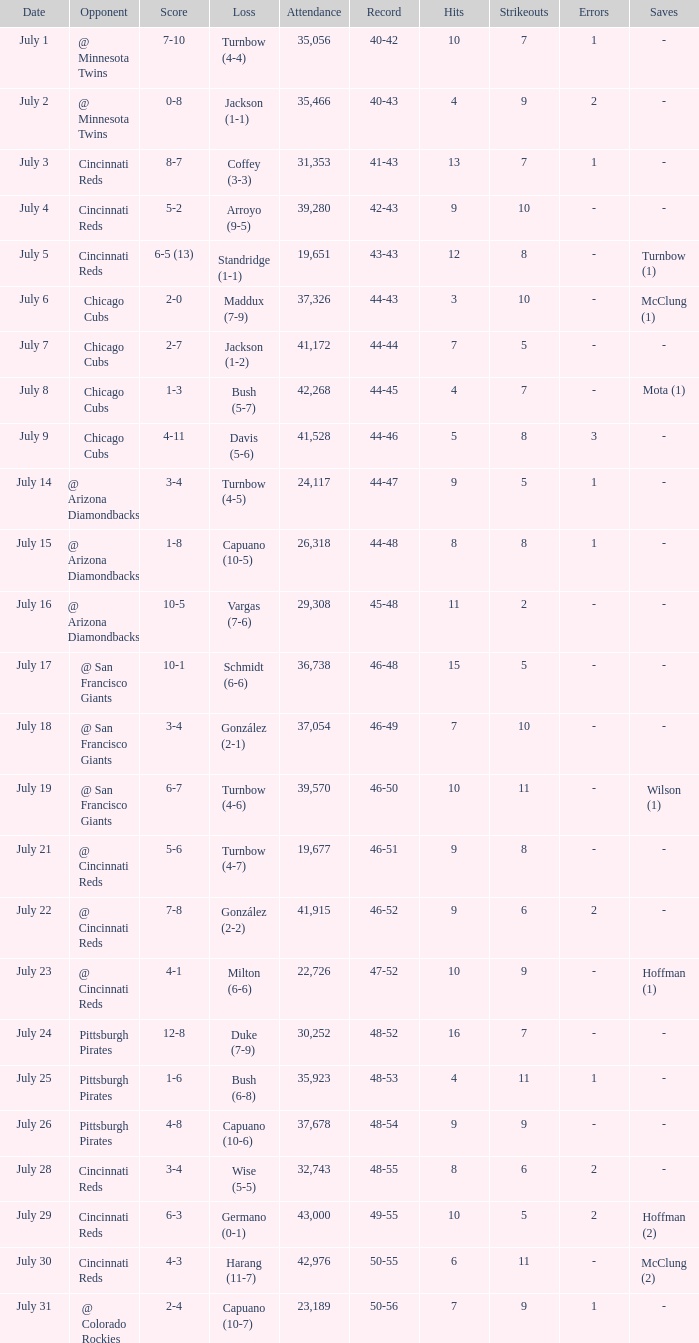What was the record at the game that had a score of 7-10? 40-42. 